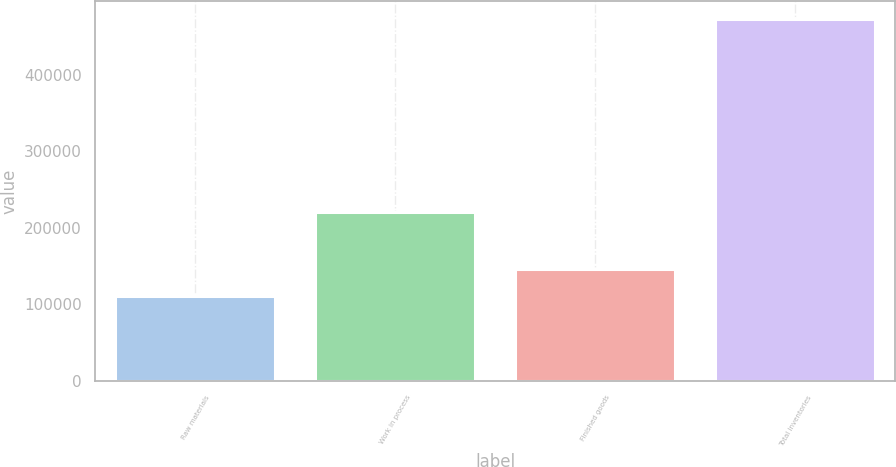Convert chart to OTSL. <chart><loc_0><loc_0><loc_500><loc_500><bar_chart><fcel>Raw materials<fcel>Work in process<fcel>Finished goods<fcel>Total inventories<nl><fcel>110389<fcel>221137<fcel>146579<fcel>472292<nl></chart> 